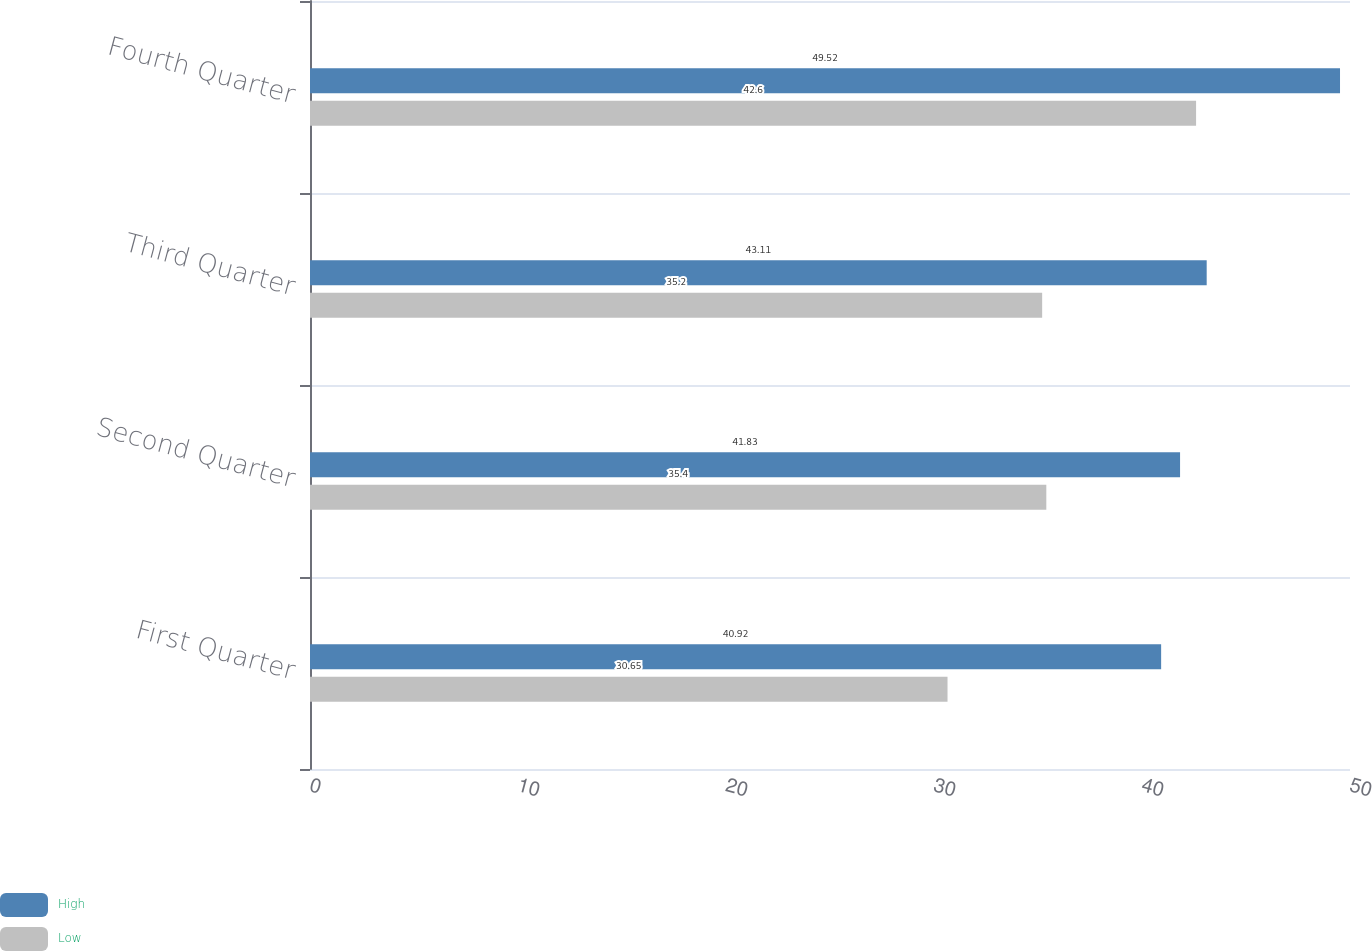Convert chart to OTSL. <chart><loc_0><loc_0><loc_500><loc_500><stacked_bar_chart><ecel><fcel>First Quarter<fcel>Second Quarter<fcel>Third Quarter<fcel>Fourth Quarter<nl><fcel>High<fcel>40.92<fcel>41.83<fcel>43.11<fcel>49.52<nl><fcel>Low<fcel>30.65<fcel>35.4<fcel>35.2<fcel>42.6<nl></chart> 